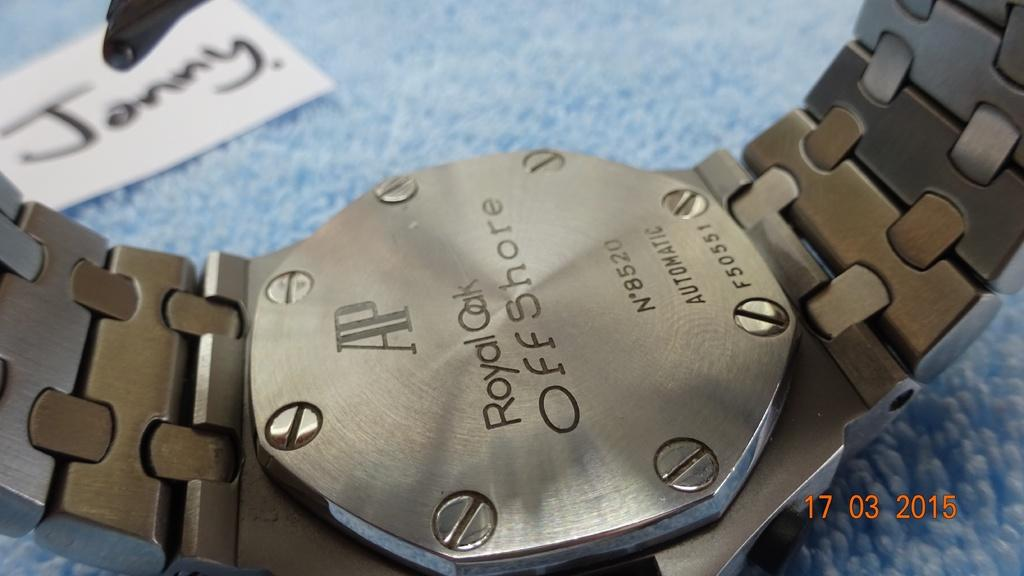<image>
Present a compact description of the photo's key features. Back of metallic AP Royal Oak Offshore men's watch with metallic scraps, octagonal shape. 